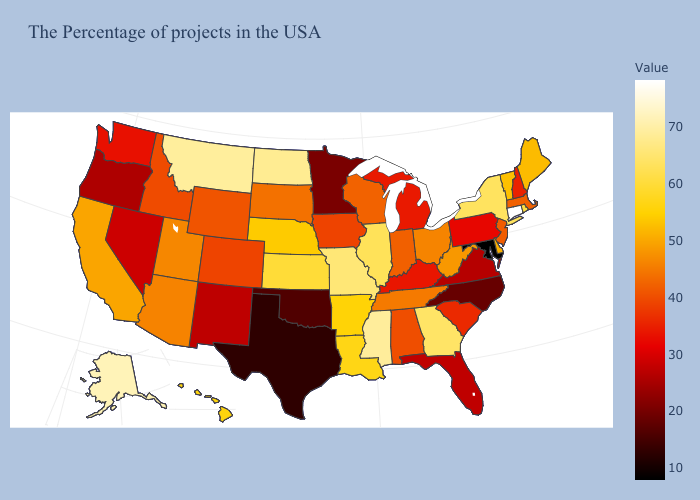Which states hav the highest value in the Northeast?
Give a very brief answer. Connecticut. Which states have the highest value in the USA?
Write a very short answer. Connecticut. Does the map have missing data?
Concise answer only. No. Does the map have missing data?
Quick response, please. No. Which states hav the highest value in the West?
Quick response, please. Alaska. Among the states that border Ohio , does Pennsylvania have the highest value?
Concise answer only. No. Does Connecticut have the highest value in the USA?
Answer briefly. Yes. 